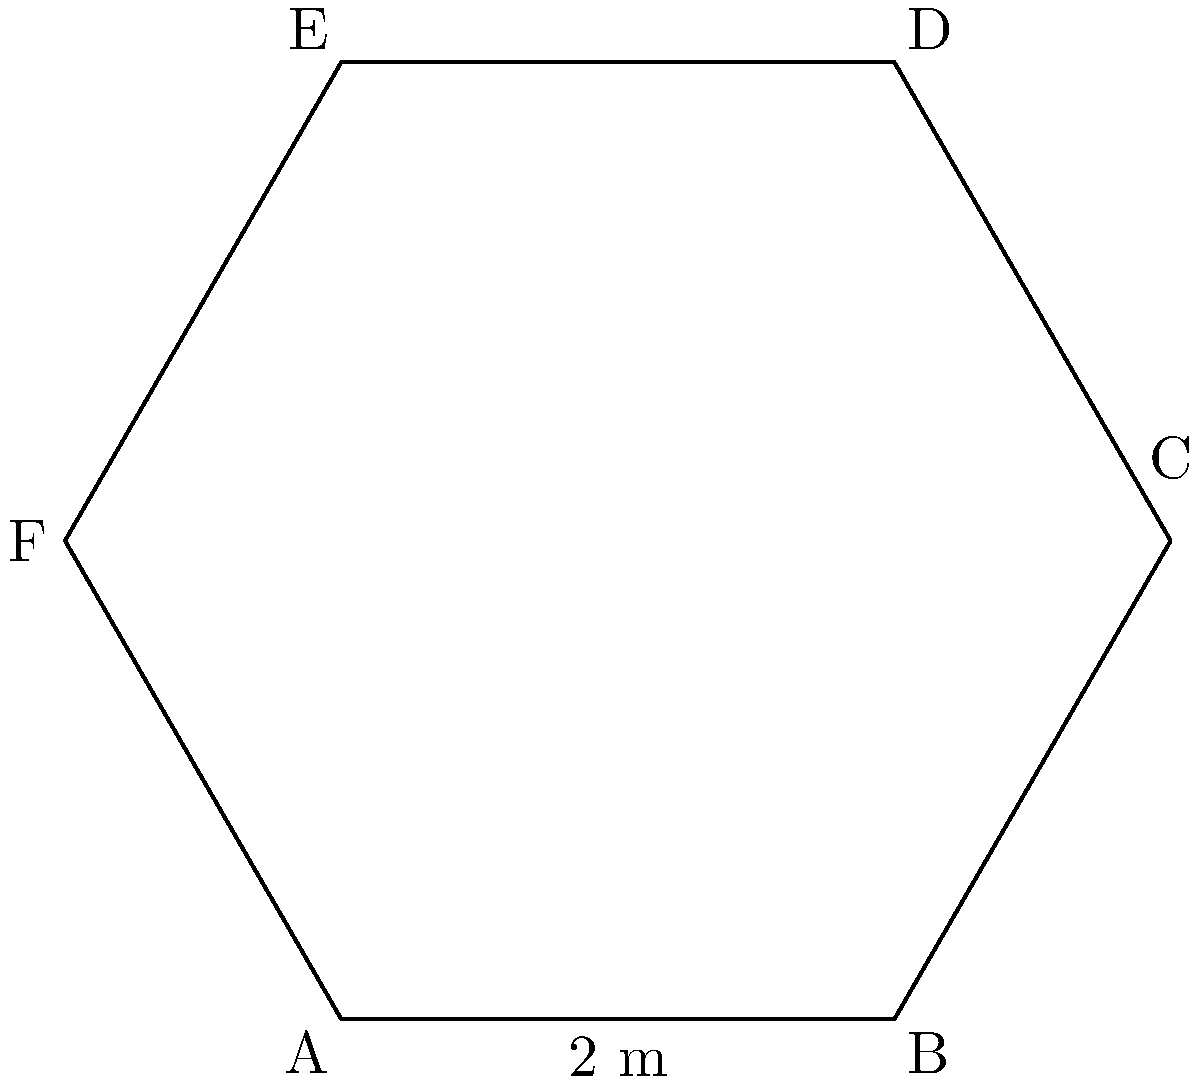Your newly renovated bar features a hexagonal-shaped counter. If one side of the hexagon measures 2 meters, as shown in the diagram, what is the total perimeter of the counter? This information will help you determine the amount of decorative trim needed for the edge of the counter, which could impact your renovation budget and potentially affect the amount you can donate to scholarships. Let's approach this step-by-step:

1) First, recall that a regular hexagon has six equal sides.

2) We're given that one side of the hexagon is 2 meters long.

3) To find the perimeter, we need to multiply the length of one side by the number of sides:

   $$ \text{Perimeter} = \text{Length of one side} \times \text{Number of sides} $$

4) Substituting our known values:

   $$ \text{Perimeter} = 2 \text{ meters} \times 6 $$

5) Calculating:

   $$ \text{Perimeter} = 12 \text{ meters} $$

Therefore, the total perimeter of the hexagonal bar counter is 12 meters.
Answer: 12 meters 